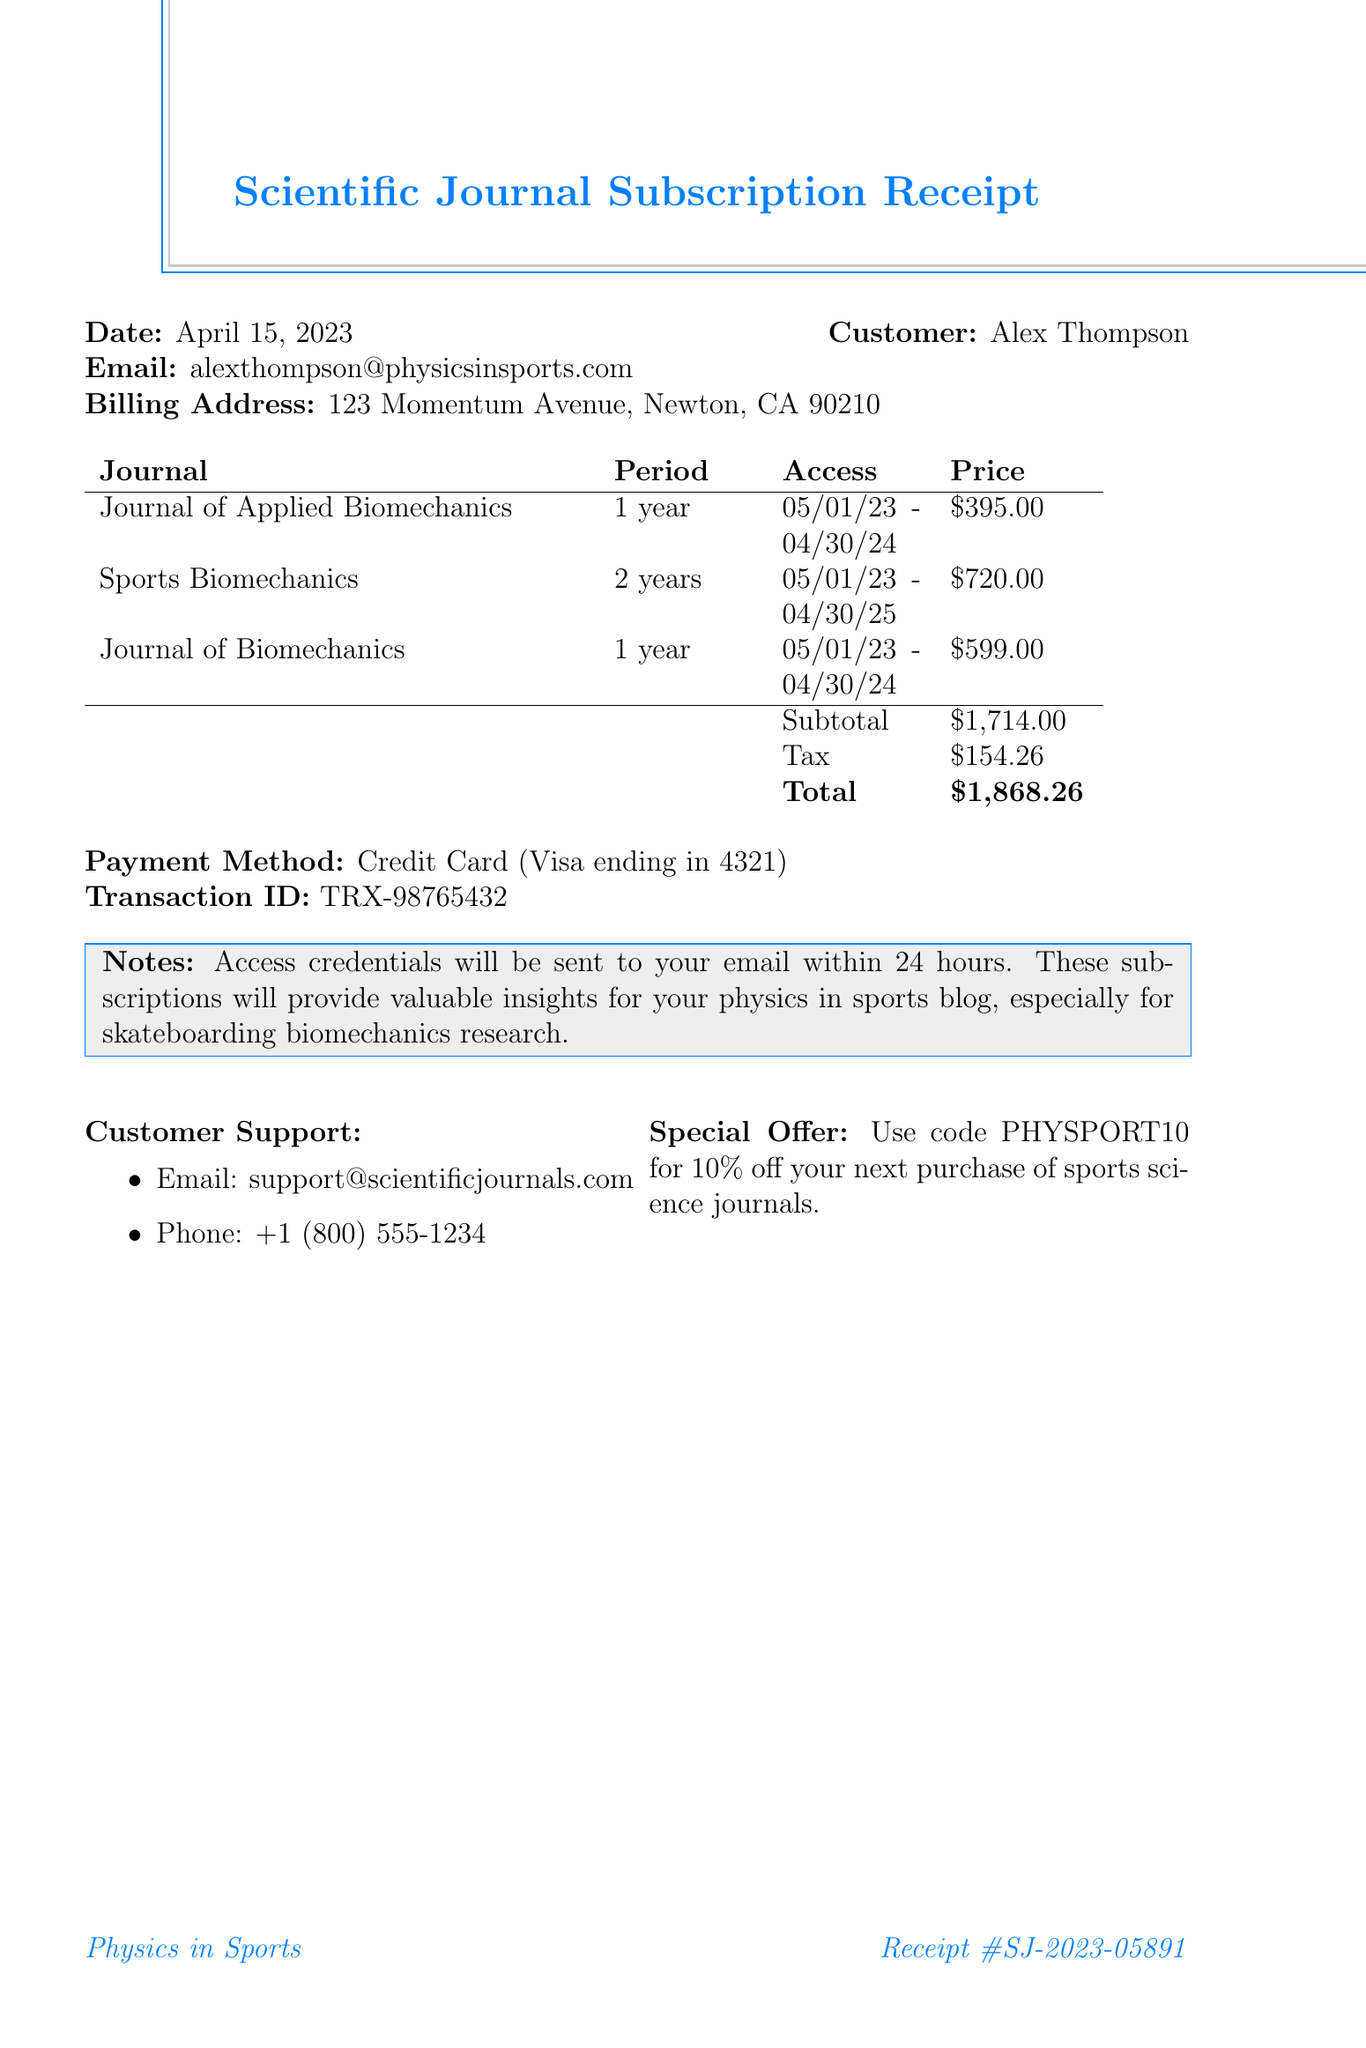What is the receipt number? The receipt number is a unique identifier for this transaction, found at the top of the document.
Answer: SJ-2023-05891 Who is the customer? The customer’s name is provided near the date section of the document.
Answer: Alex Thompson What is the total amount charged? The total amount charged is the final cost including tax, listed near the end of the receipt.
Answer: $1,868.26 How long is the subscription for the Journal of Biomechanics? The subscription period for this journal is noted in the list of items section of the document.
Answer: 1 year When does access for Sports Biomechanics start? The access start date is mentioned in the details of the subscription for Sports Biomechanics.
Answer: 2023-05-01 What payment method was used? The payment method is specified near the end of the document.
Answer: Credit Card (Visa ending in 4321) What is the publishing company for the Journal of Applied Biomechanics? The publisher's name is provided alongside the journal name in the itemized list.
Answer: Human Kinetics What is the duration of the subscription for Sports Biomechanics? The duration is detailed in the items section of the receipt, under the subscription period for the specific journal.
Answer: 2 years What is stated in the notes section regarding access credentials? This section includes information on how and when access credentials will be delivered.
Answer: Access credentials will be sent to your email within 24 hours 